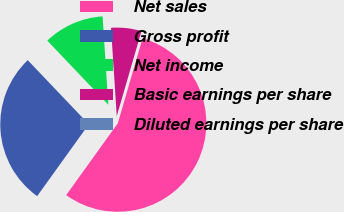Convert chart to OTSL. <chart><loc_0><loc_0><loc_500><loc_500><pie_chart><fcel>Net sales<fcel>Gross profit<fcel>Net income<fcel>Basic earnings per share<fcel>Diluted earnings per share<nl><fcel>55.41%<fcel>27.97%<fcel>11.08%<fcel>5.54%<fcel>0.0%<nl></chart> 